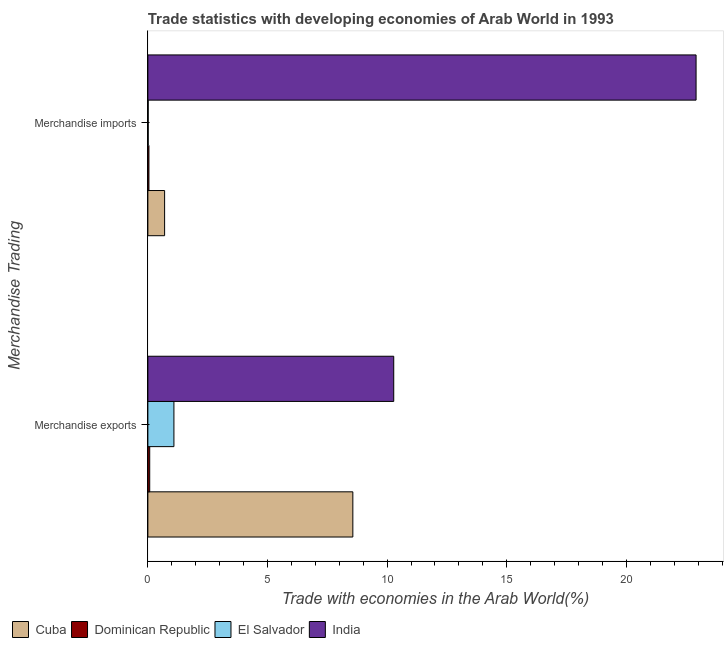How many different coloured bars are there?
Offer a very short reply. 4. How many bars are there on the 1st tick from the bottom?
Make the answer very short. 4. What is the label of the 2nd group of bars from the top?
Offer a very short reply. Merchandise exports. What is the merchandise imports in Cuba?
Your answer should be compact. 0.7. Across all countries, what is the maximum merchandise exports?
Keep it short and to the point. 10.28. Across all countries, what is the minimum merchandise exports?
Your answer should be very brief. 0.08. In which country was the merchandise exports maximum?
Give a very brief answer. India. In which country was the merchandise imports minimum?
Give a very brief answer. El Salvador. What is the total merchandise imports in the graph?
Ensure brevity in your answer.  23.67. What is the difference between the merchandise exports in El Salvador and that in Cuba?
Provide a short and direct response. -7.48. What is the difference between the merchandise exports in India and the merchandise imports in El Salvador?
Keep it short and to the point. 10.26. What is the average merchandise exports per country?
Make the answer very short. 5. What is the difference between the merchandise exports and merchandise imports in India?
Your response must be concise. -12.64. In how many countries, is the merchandise imports greater than 23 %?
Provide a short and direct response. 0. What is the ratio of the merchandise imports in India to that in Dominican Republic?
Ensure brevity in your answer.  515.38. In how many countries, is the merchandise imports greater than the average merchandise imports taken over all countries?
Ensure brevity in your answer.  1. What does the 3rd bar from the top in Merchandise exports represents?
Ensure brevity in your answer.  Dominican Republic. What does the 4th bar from the bottom in Merchandise imports represents?
Make the answer very short. India. How are the legend labels stacked?
Give a very brief answer. Horizontal. What is the title of the graph?
Offer a very short reply. Trade statistics with developing economies of Arab World in 1993. What is the label or title of the X-axis?
Provide a succinct answer. Trade with economies in the Arab World(%). What is the label or title of the Y-axis?
Give a very brief answer. Merchandise Trading. What is the Trade with economies in the Arab World(%) in Cuba in Merchandise exports?
Keep it short and to the point. 8.57. What is the Trade with economies in the Arab World(%) in Dominican Republic in Merchandise exports?
Your response must be concise. 0.08. What is the Trade with economies in the Arab World(%) of El Salvador in Merchandise exports?
Provide a short and direct response. 1.09. What is the Trade with economies in the Arab World(%) of India in Merchandise exports?
Provide a short and direct response. 10.28. What is the Trade with economies in the Arab World(%) of Cuba in Merchandise imports?
Provide a succinct answer. 0.7. What is the Trade with economies in the Arab World(%) of Dominican Republic in Merchandise imports?
Ensure brevity in your answer.  0.04. What is the Trade with economies in the Arab World(%) in El Salvador in Merchandise imports?
Provide a short and direct response. 0.01. What is the Trade with economies in the Arab World(%) in India in Merchandise imports?
Provide a succinct answer. 22.91. Across all Merchandise Trading, what is the maximum Trade with economies in the Arab World(%) in Cuba?
Give a very brief answer. 8.57. Across all Merchandise Trading, what is the maximum Trade with economies in the Arab World(%) of Dominican Republic?
Your response must be concise. 0.08. Across all Merchandise Trading, what is the maximum Trade with economies in the Arab World(%) of El Salvador?
Your response must be concise. 1.09. Across all Merchandise Trading, what is the maximum Trade with economies in the Arab World(%) in India?
Ensure brevity in your answer.  22.91. Across all Merchandise Trading, what is the minimum Trade with economies in the Arab World(%) in Cuba?
Offer a terse response. 0.7. Across all Merchandise Trading, what is the minimum Trade with economies in the Arab World(%) in Dominican Republic?
Your answer should be very brief. 0.04. Across all Merchandise Trading, what is the minimum Trade with economies in the Arab World(%) in El Salvador?
Keep it short and to the point. 0.01. Across all Merchandise Trading, what is the minimum Trade with economies in the Arab World(%) of India?
Your answer should be compact. 10.28. What is the total Trade with economies in the Arab World(%) in Cuba in the graph?
Keep it short and to the point. 9.27. What is the total Trade with economies in the Arab World(%) of Dominican Republic in the graph?
Keep it short and to the point. 0.12. What is the total Trade with economies in the Arab World(%) of El Salvador in the graph?
Ensure brevity in your answer.  1.1. What is the total Trade with economies in the Arab World(%) of India in the graph?
Keep it short and to the point. 33.19. What is the difference between the Trade with economies in the Arab World(%) in Cuba in Merchandise exports and that in Merchandise imports?
Your answer should be compact. 7.87. What is the difference between the Trade with economies in the Arab World(%) of Dominican Republic in Merchandise exports and that in Merchandise imports?
Your response must be concise. 0.03. What is the difference between the Trade with economies in the Arab World(%) in El Salvador in Merchandise exports and that in Merchandise imports?
Offer a very short reply. 1.07. What is the difference between the Trade with economies in the Arab World(%) in India in Merchandise exports and that in Merchandise imports?
Offer a very short reply. -12.64. What is the difference between the Trade with economies in the Arab World(%) in Cuba in Merchandise exports and the Trade with economies in the Arab World(%) in Dominican Republic in Merchandise imports?
Your answer should be compact. 8.52. What is the difference between the Trade with economies in the Arab World(%) in Cuba in Merchandise exports and the Trade with economies in the Arab World(%) in El Salvador in Merchandise imports?
Make the answer very short. 8.55. What is the difference between the Trade with economies in the Arab World(%) in Cuba in Merchandise exports and the Trade with economies in the Arab World(%) in India in Merchandise imports?
Your response must be concise. -14.35. What is the difference between the Trade with economies in the Arab World(%) in Dominican Republic in Merchandise exports and the Trade with economies in the Arab World(%) in El Salvador in Merchandise imports?
Ensure brevity in your answer.  0.06. What is the difference between the Trade with economies in the Arab World(%) in Dominican Republic in Merchandise exports and the Trade with economies in the Arab World(%) in India in Merchandise imports?
Offer a terse response. -22.84. What is the difference between the Trade with economies in the Arab World(%) in El Salvador in Merchandise exports and the Trade with economies in the Arab World(%) in India in Merchandise imports?
Provide a short and direct response. -21.83. What is the average Trade with economies in the Arab World(%) in Cuba per Merchandise Trading?
Your answer should be compact. 4.63. What is the average Trade with economies in the Arab World(%) in Dominican Republic per Merchandise Trading?
Ensure brevity in your answer.  0.06. What is the average Trade with economies in the Arab World(%) of El Salvador per Merchandise Trading?
Offer a terse response. 0.55. What is the average Trade with economies in the Arab World(%) of India per Merchandise Trading?
Your response must be concise. 16.6. What is the difference between the Trade with economies in the Arab World(%) of Cuba and Trade with economies in the Arab World(%) of Dominican Republic in Merchandise exports?
Your response must be concise. 8.49. What is the difference between the Trade with economies in the Arab World(%) of Cuba and Trade with economies in the Arab World(%) of El Salvador in Merchandise exports?
Ensure brevity in your answer.  7.48. What is the difference between the Trade with economies in the Arab World(%) of Cuba and Trade with economies in the Arab World(%) of India in Merchandise exports?
Give a very brief answer. -1.71. What is the difference between the Trade with economies in the Arab World(%) in Dominican Republic and Trade with economies in the Arab World(%) in El Salvador in Merchandise exports?
Your answer should be very brief. -1.01. What is the difference between the Trade with economies in the Arab World(%) in Dominican Republic and Trade with economies in the Arab World(%) in India in Merchandise exports?
Your response must be concise. -10.2. What is the difference between the Trade with economies in the Arab World(%) in El Salvador and Trade with economies in the Arab World(%) in India in Merchandise exports?
Provide a short and direct response. -9.19. What is the difference between the Trade with economies in the Arab World(%) in Cuba and Trade with economies in the Arab World(%) in Dominican Republic in Merchandise imports?
Your response must be concise. 0.66. What is the difference between the Trade with economies in the Arab World(%) of Cuba and Trade with economies in the Arab World(%) of El Salvador in Merchandise imports?
Your answer should be compact. 0.69. What is the difference between the Trade with economies in the Arab World(%) in Cuba and Trade with economies in the Arab World(%) in India in Merchandise imports?
Provide a short and direct response. -22.21. What is the difference between the Trade with economies in the Arab World(%) of Dominican Republic and Trade with economies in the Arab World(%) of El Salvador in Merchandise imports?
Your answer should be very brief. 0.03. What is the difference between the Trade with economies in the Arab World(%) of Dominican Republic and Trade with economies in the Arab World(%) of India in Merchandise imports?
Your answer should be very brief. -22.87. What is the difference between the Trade with economies in the Arab World(%) of El Salvador and Trade with economies in the Arab World(%) of India in Merchandise imports?
Make the answer very short. -22.9. What is the ratio of the Trade with economies in the Arab World(%) of Cuba in Merchandise exports to that in Merchandise imports?
Your answer should be very brief. 12.25. What is the ratio of the Trade with economies in the Arab World(%) in Dominican Republic in Merchandise exports to that in Merchandise imports?
Your response must be concise. 1.74. What is the ratio of the Trade with economies in the Arab World(%) in El Salvador in Merchandise exports to that in Merchandise imports?
Give a very brief answer. 77.01. What is the ratio of the Trade with economies in the Arab World(%) in India in Merchandise exports to that in Merchandise imports?
Give a very brief answer. 0.45. What is the difference between the highest and the second highest Trade with economies in the Arab World(%) of Cuba?
Offer a terse response. 7.87. What is the difference between the highest and the second highest Trade with economies in the Arab World(%) in Dominican Republic?
Your answer should be compact. 0.03. What is the difference between the highest and the second highest Trade with economies in the Arab World(%) of El Salvador?
Your answer should be compact. 1.07. What is the difference between the highest and the second highest Trade with economies in the Arab World(%) of India?
Your answer should be very brief. 12.64. What is the difference between the highest and the lowest Trade with economies in the Arab World(%) in Cuba?
Provide a short and direct response. 7.87. What is the difference between the highest and the lowest Trade with economies in the Arab World(%) in Dominican Republic?
Your response must be concise. 0.03. What is the difference between the highest and the lowest Trade with economies in the Arab World(%) of El Salvador?
Make the answer very short. 1.07. What is the difference between the highest and the lowest Trade with economies in the Arab World(%) in India?
Your answer should be compact. 12.64. 